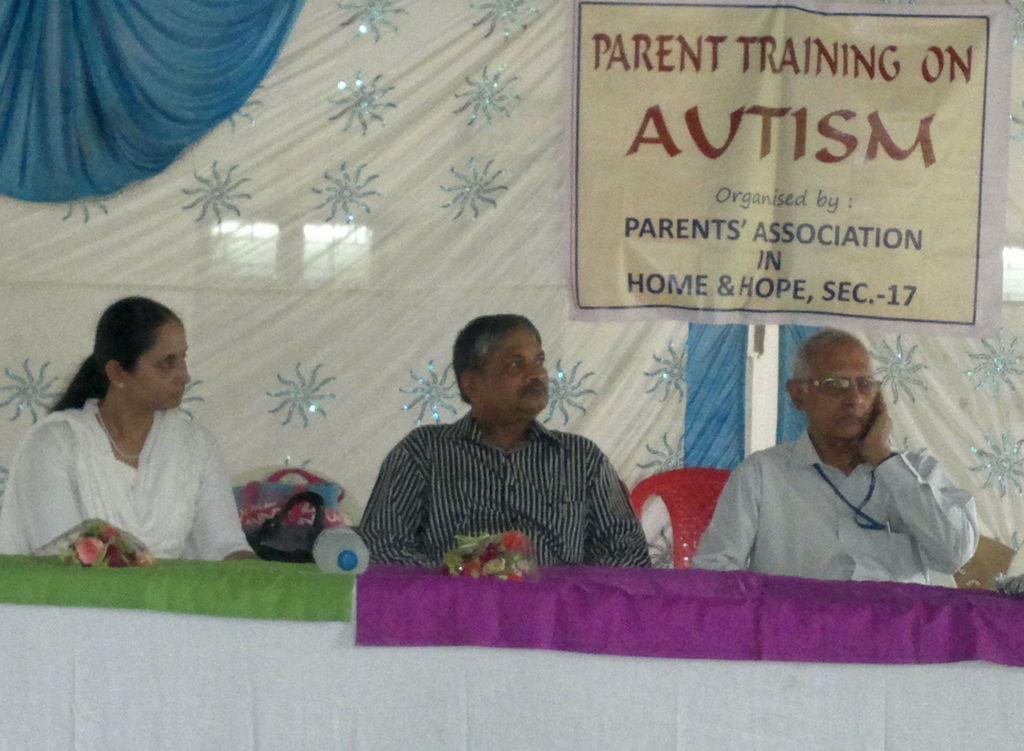Please provide a concise description of this image. In this image I can see a woman and two men are sitting on chairs. I can see she is wearing white dress and these two are wearing shirt. I can also see a bottle, few bags, a red color banner and on it I can see something is written. 